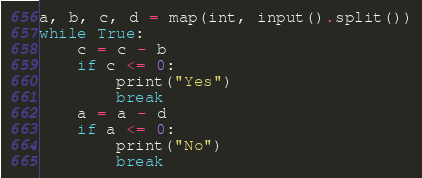<code> <loc_0><loc_0><loc_500><loc_500><_Python_>a, b, c, d = map(int, input().split())
while True:
    c = c - b
    if c <= 0:
        print("Yes")
        break
    a = a - d
    if a <= 0:
        print("No")
        break
</code> 